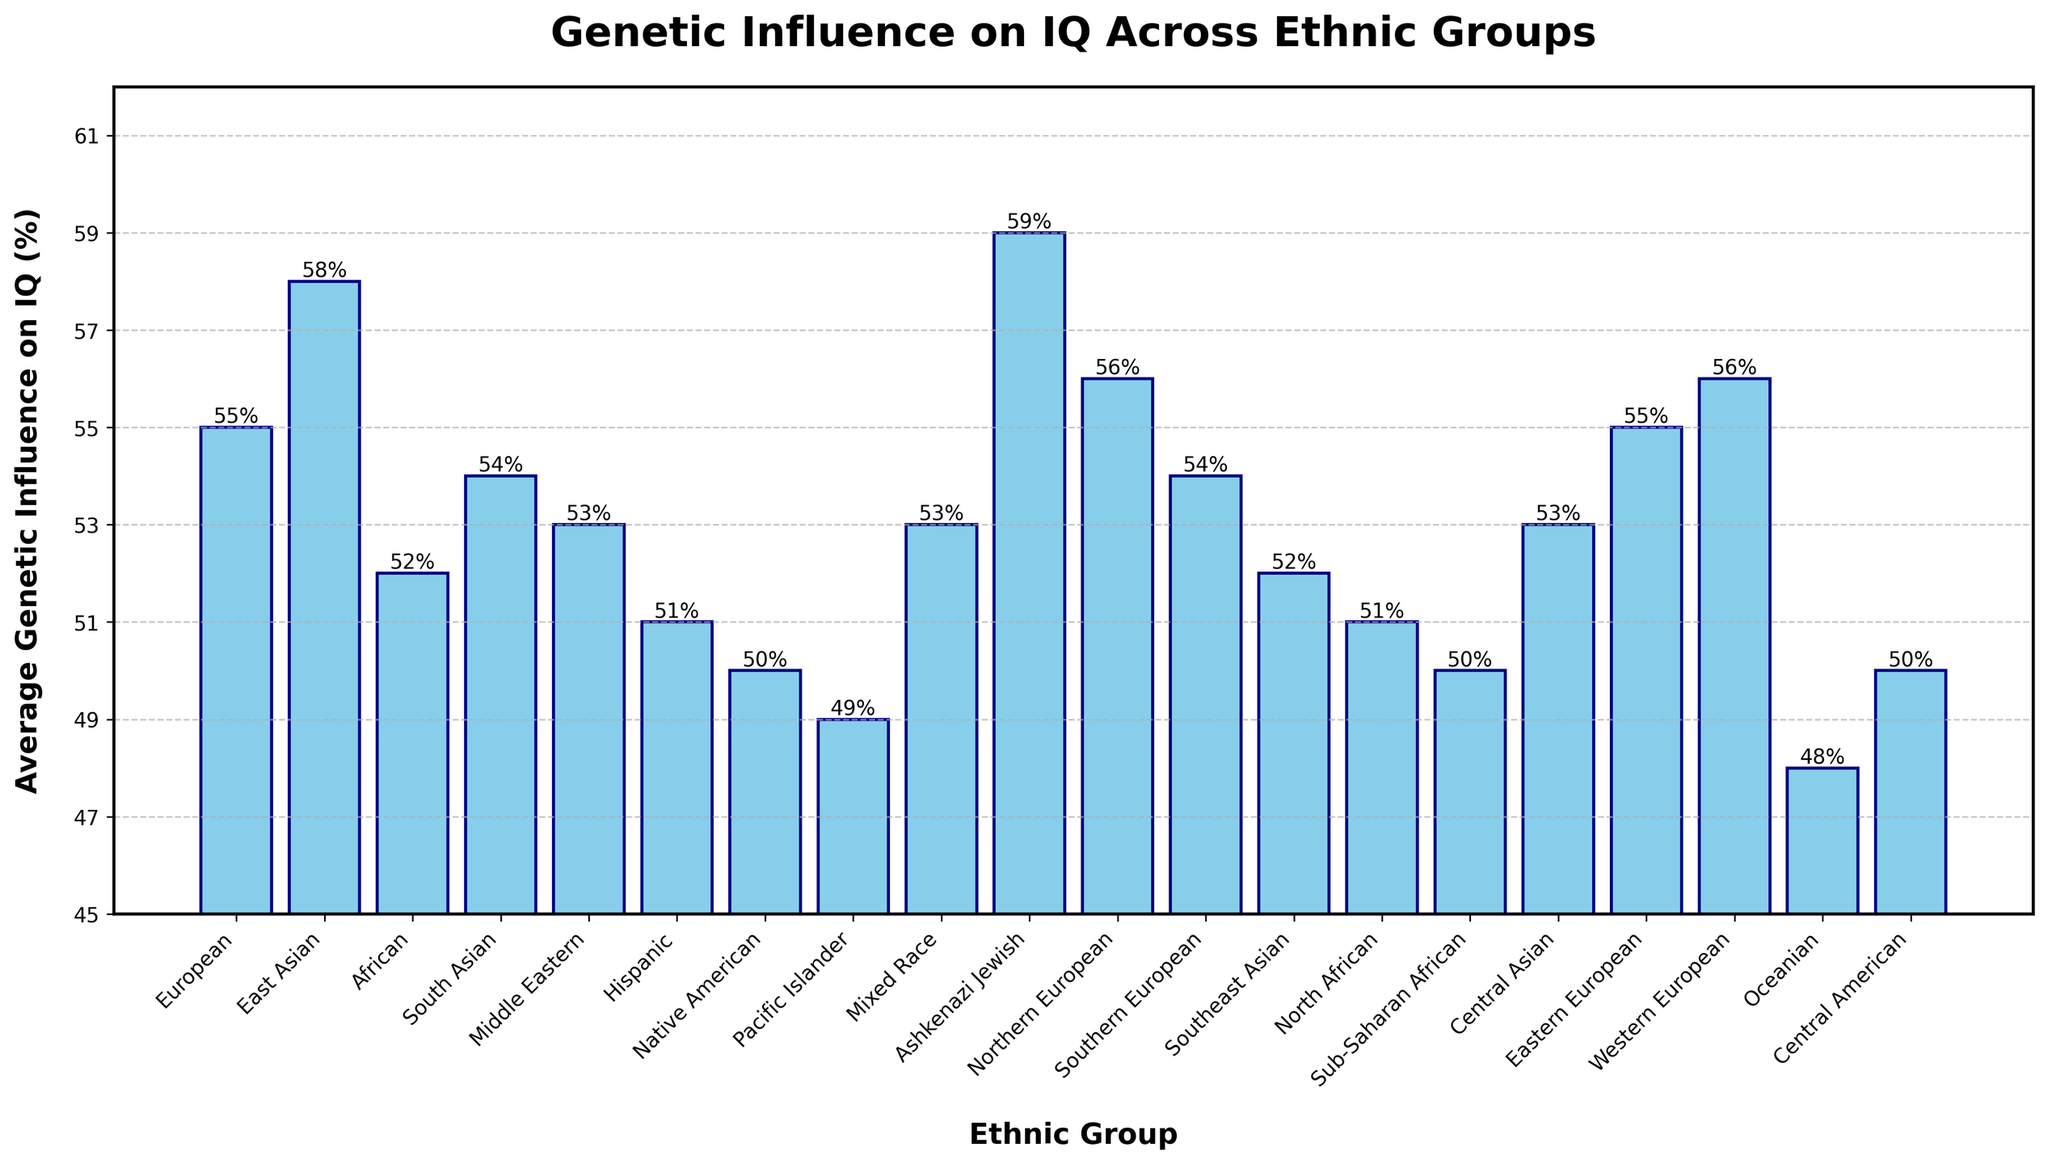Which ethnic group has the highest average genetic influence on IQ? The highest bar in the chart corresponds to the Ashkenazi Jewish group, which has the tallest bar with an average genetic influence of 59%.
Answer: Ashkenazi Jewish Which ethnic group has the lowest average genetic influence on IQ? The lowest bar in the chart corresponds to the Oceanian group, which has an average genetic influence of 48%.
Answer: Oceanian What is the average of the genetic influences of the top three ethnic groups? The top three ethnic groups with the highest genetic influences are Ashkenazi Jewish (59%), East Asian (58%), and Northern/Western European (both 56%). Therefore, the average is (59 + 58 + 56 + 56) / 3 = 229 / 3 ≈ 55.25
Answer: 55.25 How many ethnic groups have an average genetic influence of 53%? Visual inspection reveals that the bars for Middle Eastern, Mixed Race, Central Asian, and Central American groups all align with the 53% mark. Therefore, there are 4 ethnic groups with an average genetic influence of 53%.
Answer: 4 Which ethnic groups have a genetic influence on IQ between 50% and 55%? The ethnic groups within this range include South Asian (54%), Southern European (54%), Eastern European (55%), Western European (56%), African (52%), Southeast Asian (52%), North African (51%), Hispanic (51%), Native American (50%), Sub-Saharan African (50%), Central American (50%).
Answer: South Asian, Southern European, Eastern European, Western European, African, Southeast Asian, North African, Hispanic, Native American, Sub-Saharan African, Central American How does the genetic influence on IQ in Northern European compare to that of Western European? Both Northern European and Western European groups have the same average genetic influence on IQ, which is 56%.
Answer: Equal What is the total genetic influence on IQ when combining East Asian and Hispanic ethnic groups? The genetic influence for East Asians is 58%, and for Hispanics, it is 51%. Therefore, the combined total is 58 + 51 = 109%.
Answer: 109 By how many percentage points does Ashkenazi Jewish exceed Native American in average genetic influence on IQ? The average genetic influence for Ashkenazi Jewish is 59%, and for Native American, it is 50%. The difference is 59 - 50 = 9 percentage points.
Answer: 9 What is the range of average genetic influence on IQ across all ethnic groups? The highest value is 59% (Ashkenazi Jewish) and the lowest is 48% (Oceanian), so the range is 59 - 48 = 11%.
Answer: 11 How many ethnic groups have a genetic influence of 55% or higher? Visual inspection shows that Ashkenazi Jewish (59%), East Asian (58%), Northern/Western European (both 56%), Eastern European (55%), and European (55%) groups all meet this criterion. Therefore, there are 6 ethnic groups with a genetic influence of 55% or higher.
Answer: 6 